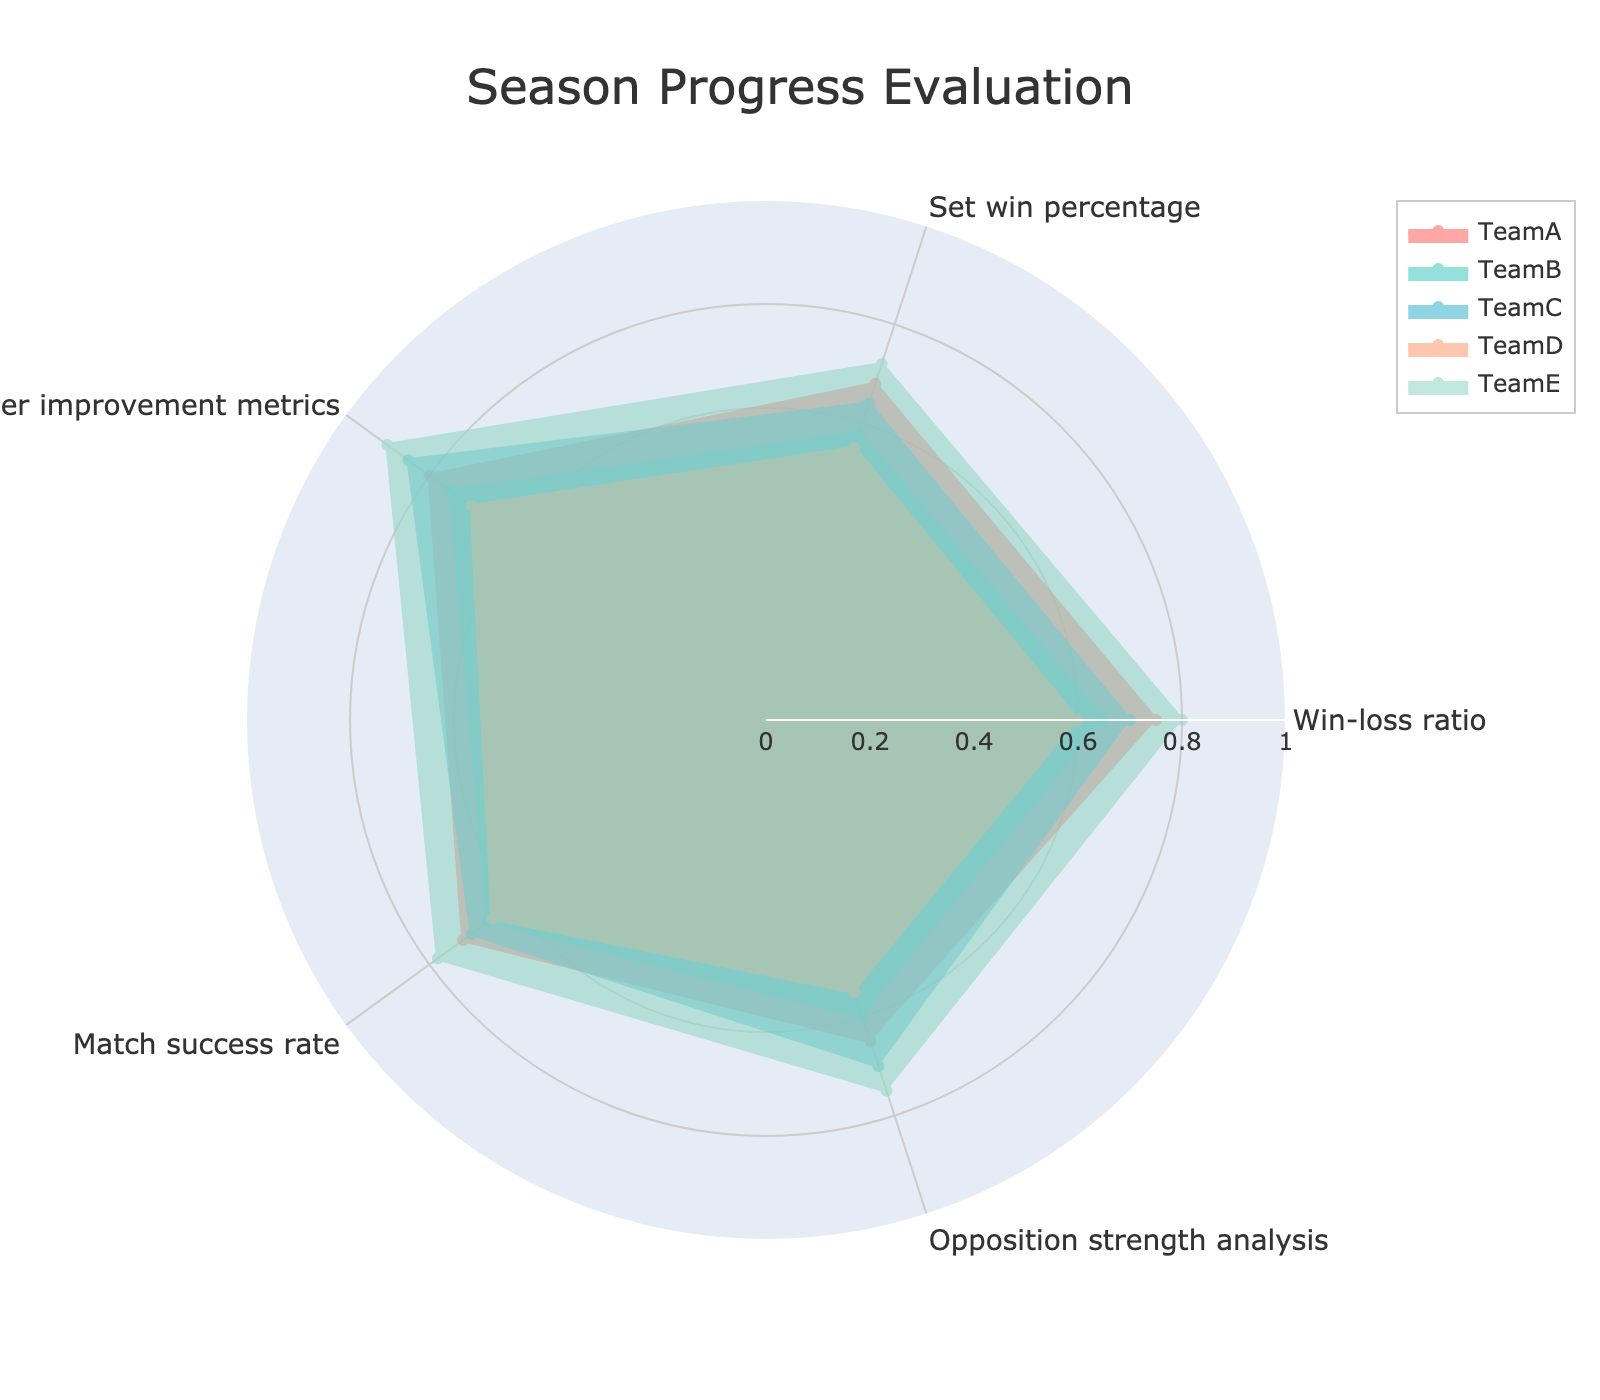What is the title of the radar chart? By looking at the top of the chart, you can identify the title.
Answer: Season Progress Evaluation What are the five metrics displayed in the radar chart? The metrics are shown as axis labels around the radar chart.
Answer: Win-loss ratio, Set win percentage, Player improvement metrics, Match success rate, Opposition strength analysis Which team has the highest win-loss ratio? Observe the length of each team's segment on the Win-loss ratio axis; the longest one indicates the highest value.
Answer: Team E Which team shows the most balanced performance across all metrics? Look at which team's area shape is most equally distributed across all axes, meaning the lengths of the segments are similar in each metric.
Answer: Team C What is the average match success rate of all teams? Sum the match success rates of all teams and divide by the number of teams: (0.72 + 0.66 + 0.7 + 0.65 + 0.78) / 5 = 3.51 / 5 = 0.702.
Answer: 0.702 Which team has the lowest opposition strength analysis score? Compare the lengths of each team's segment on the Opposition strength analysis axis; the shortest one is the lowest.
Answer: Team D How does Team B's player improvement metrics compare to Team A's player improvement metrics? Check the values of the Player improvement metrics axis for both Team B and Team A, then compare them. Team B has 0.75 whereas Team A has 0.8.
Answer: Team B has a lower player improvement metrics score than Team A What is the difference in the set win percentage between Team D and Team E? Subtract Team D's set win percentage (0.55) from Team E's set win percentage (0.72): 0.72 - 0.55 = 0.17.
Answer: 0.17 Which team has the highest score in player improvement metrics? Check which team's segment extends the furthest on the Player improvement metrics axis.
Answer: Team E Does any team have a perfect score in any metric? A perfect score would be a segment reaching 1.0 on an axis. Check if any team's segment extends to 1.0 for any metric.
Answer: No 